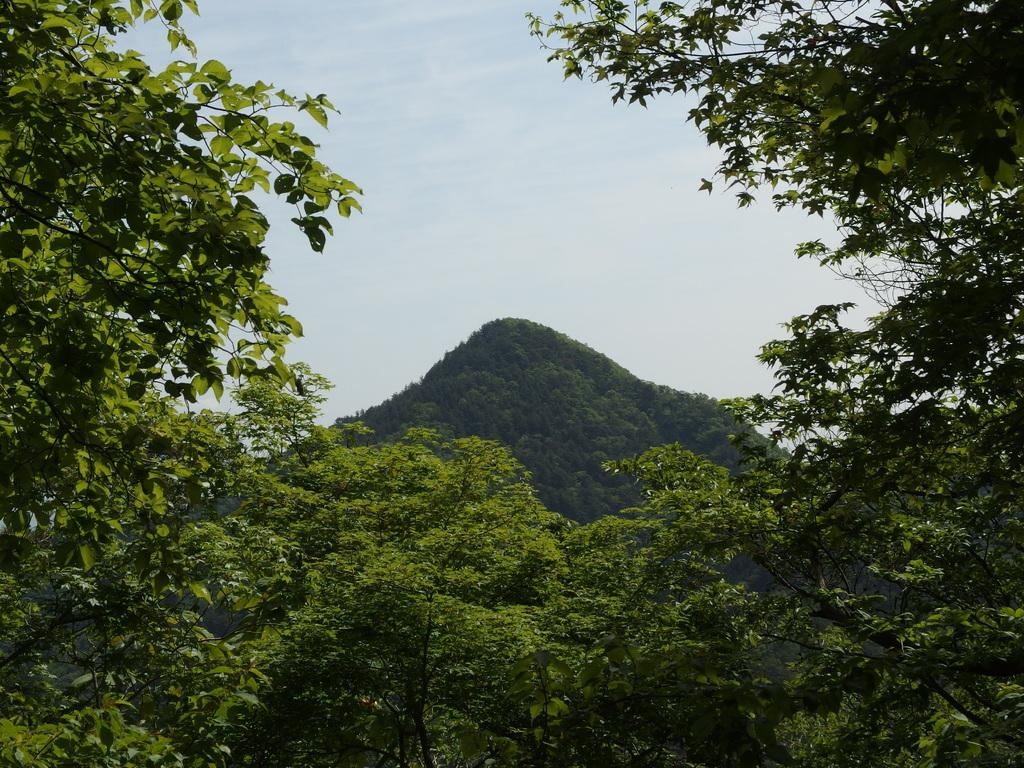What type of vegetation can be seen in the image? There are many trees in the image. What is visible in the background of the image? There is a mountain in the background of the image. What part of the natural environment is visible in the image? The sky is visible in the image. What can be seen in the sky? Clouds are present in the sky. How many cents are visible in the image? There are no cents present in the image. What type of pickle can be seen growing on the trees in the image? There are no pickles present in the image, as it features trees and a mountain. 